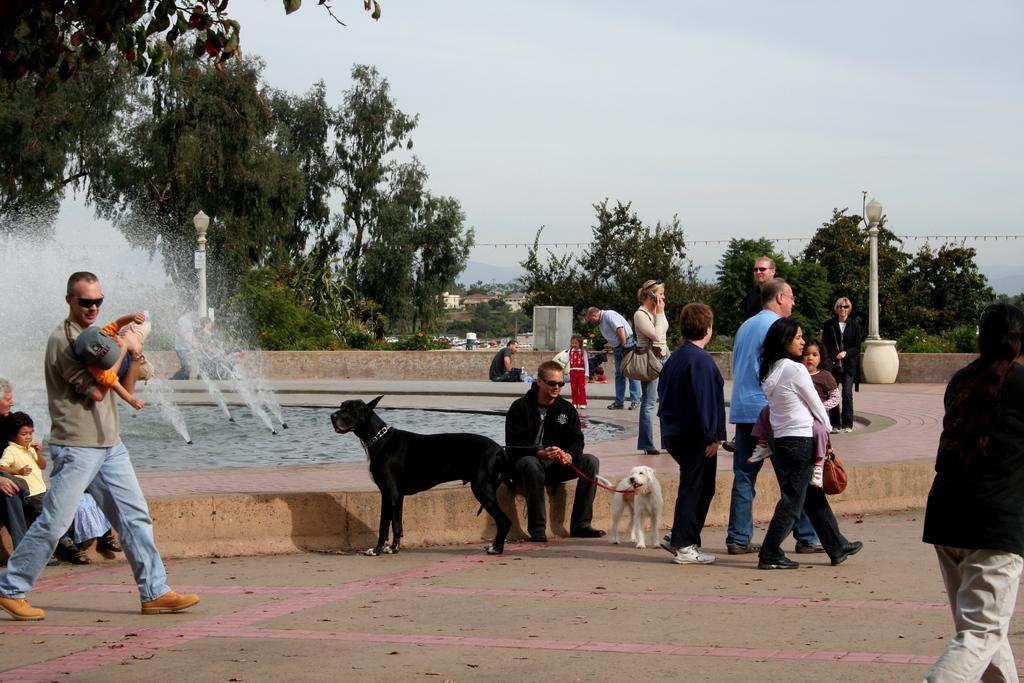How would you summarize this image in a sentence or two? There is a group of people. Some persons are standing,some persons are walking and some persons are sitting. On the right side of the woman is carrying a girl. She is wearing a bag. On the left side of the person is walking and he is carrying a person and he is wearing a spectacle. In the center of the person is sitting on a path. he is holding a dog chain. We can see in the background trees,sky,water fountain and pole. 